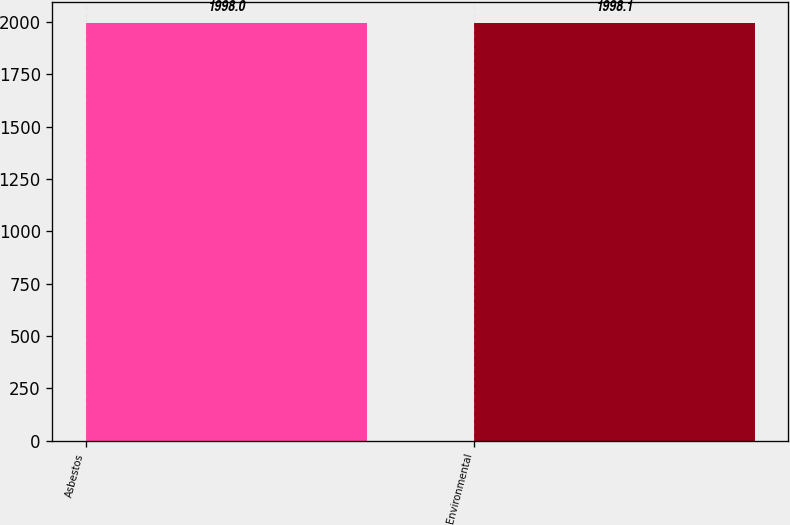Convert chart. <chart><loc_0><loc_0><loc_500><loc_500><bar_chart><fcel>Asbestos<fcel>Environmental<nl><fcel>1998<fcel>1998.1<nl></chart> 